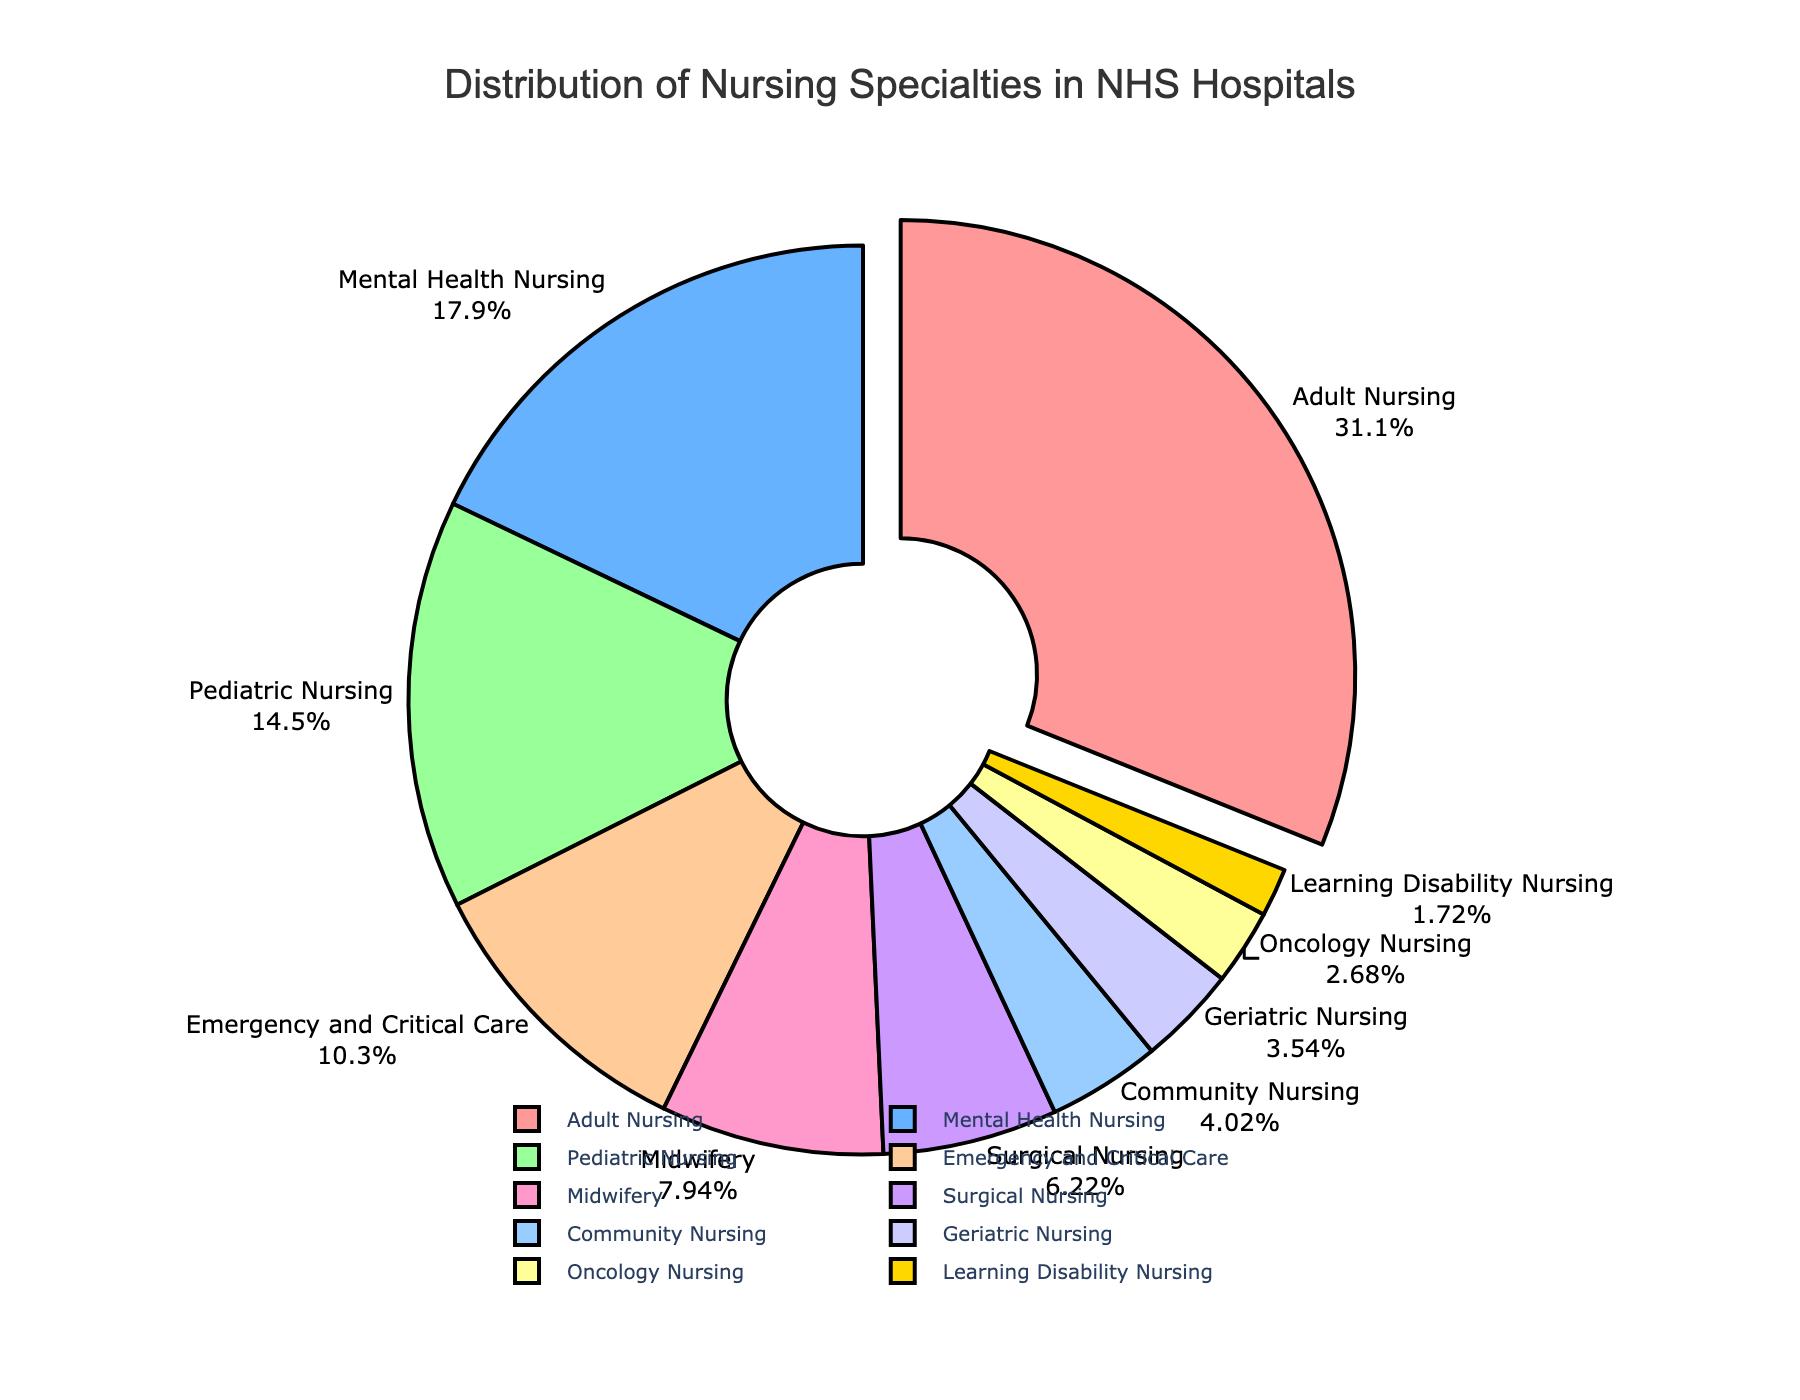Which nursing specialty has the highest percentage in NHS hospitals? The pie chart shows that Adult Nursing has the largest segment, thus the highest percentage.
Answer: Adult Nursing Which three nursing specialties have the lowest percentages? The three smallest segments in the pie chart, moving clockwise from Adult Nursing, are Learning Disability Nursing, Oncology Nursing, and Community Nursing.
Answer: Learning Disability Nursing, Oncology Nursing, Community Nursing How much greater is the percentage of Mental Health Nursing compared to Geriatric Nursing? Mental Health Nursing has a percentage of 18.7%, and Geriatric Nursing has 3.7%. The difference is calculated as 18.7% - 3.7%.
Answer: 15% Is the percentage of Pediatric Nursing higher or lower than Midwifery? The pie chart shows that Pediatric Nursing has a segment of 15.2%, which is larger than Midwifery's segment of 8.3%.
Answer: Higher Which specialty accounts for roughly one-third of the nursing distribution? Adult Nursing has a percentage of 32.5%, which is close to one-third of the total distribution.
Answer: Adult Nursing What is the combined percentage of Surgical Nursing and Emergency and Critical Care? Surgical Nursing has a percentage of 6.5%, and Emergency and Critical Care has 10.8%. Adding these together, we get 6.5% + 10.8%.
Answer: 17.3% What is the color of the segment representing Midwifery? The segment for Midwifery is colored pink, as indicated by its distinct visual cue in the pie chart.
Answer: Pink Compare and find the difference in percentage between Community Nursing and Mental Health Nursing. Community Nursing has 4.2%, and Mental Health Nursing has 18.7%. The difference is calculated as 18.7% - 4.2%.
Answer: 14.5% If Oncology Nursing, Geriatric Nursing, and Learning Disability Nursing percentages are summed, do they exceed Midwifery's percentage? Sum the percentages: Oncology Nursing (2.8%) + Geriatric Nursing (3.7%) + Learning Disability Nursing (1.8%) = 8.3%, which is equal to Midwifery's percentage of 8.3%.
Answer: No What is the visual cue used to emphasize the largest segment in the pie chart? The largest segment, which is Adult Nursing, is visually emphasized by being pulled out slightly from the rest of the pie chart.
Answer: Pulled out segment 